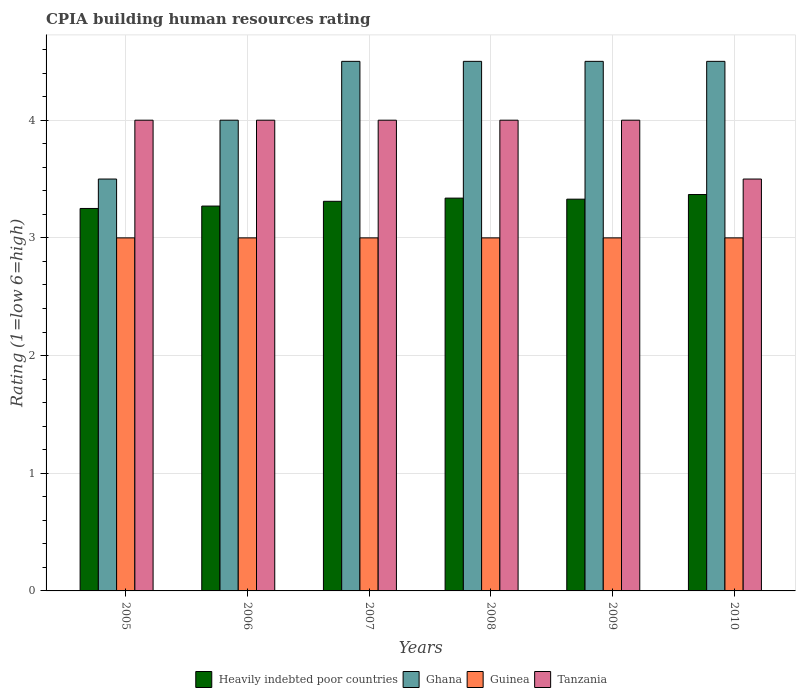Are the number of bars per tick equal to the number of legend labels?
Your response must be concise. Yes. Are the number of bars on each tick of the X-axis equal?
Keep it short and to the point. Yes. How many bars are there on the 5th tick from the left?
Provide a succinct answer. 4. What is the label of the 5th group of bars from the left?
Provide a short and direct response. 2009. What is the CPIA rating in Heavily indebted poor countries in 2009?
Give a very brief answer. 3.33. Across all years, what is the minimum CPIA rating in Tanzania?
Ensure brevity in your answer.  3.5. In which year was the CPIA rating in Guinea minimum?
Your response must be concise. 2005. What is the total CPIA rating in Tanzania in the graph?
Give a very brief answer. 23.5. What is the difference between the CPIA rating in Guinea in 2006 and that in 2008?
Offer a terse response. 0. What is the difference between the CPIA rating in Heavily indebted poor countries in 2008 and the CPIA rating in Ghana in 2006?
Ensure brevity in your answer.  -0.66. What is the average CPIA rating in Ghana per year?
Offer a terse response. 4.25. In the year 2008, what is the difference between the CPIA rating in Heavily indebted poor countries and CPIA rating in Guinea?
Keep it short and to the point. 0.34. In how many years, is the CPIA rating in Guinea greater than 0.6000000000000001?
Provide a succinct answer. 6. What is the ratio of the CPIA rating in Ghana in 2006 to that in 2007?
Your answer should be compact. 0.89. Is the difference between the CPIA rating in Heavily indebted poor countries in 2009 and 2010 greater than the difference between the CPIA rating in Guinea in 2009 and 2010?
Offer a terse response. No. What is the difference between the highest and the lowest CPIA rating in Tanzania?
Provide a succinct answer. 0.5. What does the 3rd bar from the right in 2009 represents?
Ensure brevity in your answer.  Ghana. How many years are there in the graph?
Your answer should be very brief. 6. Are the values on the major ticks of Y-axis written in scientific E-notation?
Your answer should be compact. No. Does the graph contain grids?
Give a very brief answer. Yes. What is the title of the graph?
Your response must be concise. CPIA building human resources rating. Does "Iraq" appear as one of the legend labels in the graph?
Offer a very short reply. No. What is the label or title of the Y-axis?
Give a very brief answer. Rating (1=low 6=high). What is the Rating (1=low 6=high) of Ghana in 2005?
Offer a very short reply. 3.5. What is the Rating (1=low 6=high) of Guinea in 2005?
Make the answer very short. 3. What is the Rating (1=low 6=high) of Tanzania in 2005?
Make the answer very short. 4. What is the Rating (1=low 6=high) of Heavily indebted poor countries in 2006?
Keep it short and to the point. 3.27. What is the Rating (1=low 6=high) of Heavily indebted poor countries in 2007?
Offer a very short reply. 3.31. What is the Rating (1=low 6=high) in Guinea in 2007?
Keep it short and to the point. 3. What is the Rating (1=low 6=high) of Heavily indebted poor countries in 2008?
Provide a short and direct response. 3.34. What is the Rating (1=low 6=high) in Tanzania in 2008?
Provide a succinct answer. 4. What is the Rating (1=low 6=high) in Heavily indebted poor countries in 2009?
Your answer should be very brief. 3.33. What is the Rating (1=low 6=high) in Ghana in 2009?
Offer a very short reply. 4.5. What is the Rating (1=low 6=high) in Heavily indebted poor countries in 2010?
Give a very brief answer. 3.37. What is the Rating (1=low 6=high) of Ghana in 2010?
Offer a very short reply. 4.5. What is the Rating (1=low 6=high) in Tanzania in 2010?
Your answer should be compact. 3.5. Across all years, what is the maximum Rating (1=low 6=high) of Heavily indebted poor countries?
Offer a terse response. 3.37. Across all years, what is the maximum Rating (1=low 6=high) in Ghana?
Make the answer very short. 4.5. Across all years, what is the maximum Rating (1=low 6=high) of Tanzania?
Your response must be concise. 4. Across all years, what is the minimum Rating (1=low 6=high) of Tanzania?
Make the answer very short. 3.5. What is the total Rating (1=low 6=high) in Heavily indebted poor countries in the graph?
Offer a terse response. 19.87. What is the total Rating (1=low 6=high) in Ghana in the graph?
Offer a terse response. 25.5. What is the total Rating (1=low 6=high) in Tanzania in the graph?
Make the answer very short. 23.5. What is the difference between the Rating (1=low 6=high) in Heavily indebted poor countries in 2005 and that in 2006?
Your answer should be very brief. -0.02. What is the difference between the Rating (1=low 6=high) of Tanzania in 2005 and that in 2006?
Ensure brevity in your answer.  0. What is the difference between the Rating (1=low 6=high) of Heavily indebted poor countries in 2005 and that in 2007?
Keep it short and to the point. -0.06. What is the difference between the Rating (1=low 6=high) of Ghana in 2005 and that in 2007?
Ensure brevity in your answer.  -1. What is the difference between the Rating (1=low 6=high) of Guinea in 2005 and that in 2007?
Provide a short and direct response. 0. What is the difference between the Rating (1=low 6=high) of Heavily indebted poor countries in 2005 and that in 2008?
Keep it short and to the point. -0.09. What is the difference between the Rating (1=low 6=high) in Ghana in 2005 and that in 2008?
Provide a short and direct response. -1. What is the difference between the Rating (1=low 6=high) in Tanzania in 2005 and that in 2008?
Ensure brevity in your answer.  0. What is the difference between the Rating (1=low 6=high) in Heavily indebted poor countries in 2005 and that in 2009?
Ensure brevity in your answer.  -0.08. What is the difference between the Rating (1=low 6=high) of Ghana in 2005 and that in 2009?
Provide a succinct answer. -1. What is the difference between the Rating (1=low 6=high) of Guinea in 2005 and that in 2009?
Your answer should be very brief. 0. What is the difference between the Rating (1=low 6=high) in Tanzania in 2005 and that in 2009?
Keep it short and to the point. 0. What is the difference between the Rating (1=low 6=high) of Heavily indebted poor countries in 2005 and that in 2010?
Provide a succinct answer. -0.12. What is the difference between the Rating (1=low 6=high) of Ghana in 2005 and that in 2010?
Give a very brief answer. -1. What is the difference between the Rating (1=low 6=high) of Tanzania in 2005 and that in 2010?
Provide a succinct answer. 0.5. What is the difference between the Rating (1=low 6=high) of Heavily indebted poor countries in 2006 and that in 2007?
Your answer should be compact. -0.04. What is the difference between the Rating (1=low 6=high) of Heavily indebted poor countries in 2006 and that in 2008?
Provide a succinct answer. -0.07. What is the difference between the Rating (1=low 6=high) in Guinea in 2006 and that in 2008?
Your answer should be compact. 0. What is the difference between the Rating (1=low 6=high) of Heavily indebted poor countries in 2006 and that in 2009?
Your response must be concise. -0.06. What is the difference between the Rating (1=low 6=high) of Guinea in 2006 and that in 2009?
Ensure brevity in your answer.  0. What is the difference between the Rating (1=low 6=high) of Heavily indebted poor countries in 2006 and that in 2010?
Offer a very short reply. -0.1. What is the difference between the Rating (1=low 6=high) of Ghana in 2006 and that in 2010?
Keep it short and to the point. -0.5. What is the difference between the Rating (1=low 6=high) in Tanzania in 2006 and that in 2010?
Provide a short and direct response. 0.5. What is the difference between the Rating (1=low 6=high) in Heavily indebted poor countries in 2007 and that in 2008?
Provide a short and direct response. -0.03. What is the difference between the Rating (1=low 6=high) of Guinea in 2007 and that in 2008?
Provide a short and direct response. 0. What is the difference between the Rating (1=low 6=high) in Tanzania in 2007 and that in 2008?
Provide a short and direct response. 0. What is the difference between the Rating (1=low 6=high) of Heavily indebted poor countries in 2007 and that in 2009?
Offer a very short reply. -0.02. What is the difference between the Rating (1=low 6=high) of Ghana in 2007 and that in 2009?
Offer a terse response. 0. What is the difference between the Rating (1=low 6=high) in Tanzania in 2007 and that in 2009?
Ensure brevity in your answer.  0. What is the difference between the Rating (1=low 6=high) in Heavily indebted poor countries in 2007 and that in 2010?
Keep it short and to the point. -0.06. What is the difference between the Rating (1=low 6=high) in Guinea in 2007 and that in 2010?
Provide a succinct answer. 0. What is the difference between the Rating (1=low 6=high) in Tanzania in 2007 and that in 2010?
Make the answer very short. 0.5. What is the difference between the Rating (1=low 6=high) in Heavily indebted poor countries in 2008 and that in 2009?
Make the answer very short. 0.01. What is the difference between the Rating (1=low 6=high) of Tanzania in 2008 and that in 2009?
Give a very brief answer. 0. What is the difference between the Rating (1=low 6=high) in Heavily indebted poor countries in 2008 and that in 2010?
Offer a very short reply. -0.03. What is the difference between the Rating (1=low 6=high) in Ghana in 2008 and that in 2010?
Provide a succinct answer. 0. What is the difference between the Rating (1=low 6=high) of Guinea in 2008 and that in 2010?
Your answer should be very brief. 0. What is the difference between the Rating (1=low 6=high) of Tanzania in 2008 and that in 2010?
Your answer should be very brief. 0.5. What is the difference between the Rating (1=low 6=high) in Heavily indebted poor countries in 2009 and that in 2010?
Provide a succinct answer. -0.04. What is the difference between the Rating (1=low 6=high) of Ghana in 2009 and that in 2010?
Offer a terse response. 0. What is the difference between the Rating (1=low 6=high) of Guinea in 2009 and that in 2010?
Provide a short and direct response. 0. What is the difference between the Rating (1=low 6=high) in Heavily indebted poor countries in 2005 and the Rating (1=low 6=high) in Ghana in 2006?
Make the answer very short. -0.75. What is the difference between the Rating (1=low 6=high) in Heavily indebted poor countries in 2005 and the Rating (1=low 6=high) in Tanzania in 2006?
Provide a short and direct response. -0.75. What is the difference between the Rating (1=low 6=high) in Ghana in 2005 and the Rating (1=low 6=high) in Guinea in 2006?
Your answer should be very brief. 0.5. What is the difference between the Rating (1=low 6=high) of Ghana in 2005 and the Rating (1=low 6=high) of Tanzania in 2006?
Offer a very short reply. -0.5. What is the difference between the Rating (1=low 6=high) in Guinea in 2005 and the Rating (1=low 6=high) in Tanzania in 2006?
Ensure brevity in your answer.  -1. What is the difference between the Rating (1=low 6=high) in Heavily indebted poor countries in 2005 and the Rating (1=low 6=high) in Ghana in 2007?
Your answer should be very brief. -1.25. What is the difference between the Rating (1=low 6=high) of Heavily indebted poor countries in 2005 and the Rating (1=low 6=high) of Tanzania in 2007?
Your answer should be compact. -0.75. What is the difference between the Rating (1=low 6=high) in Ghana in 2005 and the Rating (1=low 6=high) in Guinea in 2007?
Provide a succinct answer. 0.5. What is the difference between the Rating (1=low 6=high) in Ghana in 2005 and the Rating (1=low 6=high) in Tanzania in 2007?
Keep it short and to the point. -0.5. What is the difference between the Rating (1=low 6=high) in Heavily indebted poor countries in 2005 and the Rating (1=low 6=high) in Ghana in 2008?
Make the answer very short. -1.25. What is the difference between the Rating (1=low 6=high) in Heavily indebted poor countries in 2005 and the Rating (1=low 6=high) in Guinea in 2008?
Offer a terse response. 0.25. What is the difference between the Rating (1=low 6=high) in Heavily indebted poor countries in 2005 and the Rating (1=low 6=high) in Tanzania in 2008?
Offer a very short reply. -0.75. What is the difference between the Rating (1=low 6=high) of Ghana in 2005 and the Rating (1=low 6=high) of Tanzania in 2008?
Offer a very short reply. -0.5. What is the difference between the Rating (1=low 6=high) of Heavily indebted poor countries in 2005 and the Rating (1=low 6=high) of Ghana in 2009?
Ensure brevity in your answer.  -1.25. What is the difference between the Rating (1=low 6=high) of Heavily indebted poor countries in 2005 and the Rating (1=low 6=high) of Tanzania in 2009?
Offer a terse response. -0.75. What is the difference between the Rating (1=low 6=high) of Ghana in 2005 and the Rating (1=low 6=high) of Guinea in 2009?
Offer a very short reply. 0.5. What is the difference between the Rating (1=low 6=high) of Ghana in 2005 and the Rating (1=low 6=high) of Tanzania in 2009?
Your answer should be very brief. -0.5. What is the difference between the Rating (1=low 6=high) in Guinea in 2005 and the Rating (1=low 6=high) in Tanzania in 2009?
Make the answer very short. -1. What is the difference between the Rating (1=low 6=high) of Heavily indebted poor countries in 2005 and the Rating (1=low 6=high) of Ghana in 2010?
Ensure brevity in your answer.  -1.25. What is the difference between the Rating (1=low 6=high) in Ghana in 2005 and the Rating (1=low 6=high) in Guinea in 2010?
Give a very brief answer. 0.5. What is the difference between the Rating (1=low 6=high) of Heavily indebted poor countries in 2006 and the Rating (1=low 6=high) of Ghana in 2007?
Offer a terse response. -1.23. What is the difference between the Rating (1=low 6=high) of Heavily indebted poor countries in 2006 and the Rating (1=low 6=high) of Guinea in 2007?
Your answer should be very brief. 0.27. What is the difference between the Rating (1=low 6=high) of Heavily indebted poor countries in 2006 and the Rating (1=low 6=high) of Tanzania in 2007?
Provide a short and direct response. -0.73. What is the difference between the Rating (1=low 6=high) of Heavily indebted poor countries in 2006 and the Rating (1=low 6=high) of Ghana in 2008?
Your answer should be very brief. -1.23. What is the difference between the Rating (1=low 6=high) of Heavily indebted poor countries in 2006 and the Rating (1=low 6=high) of Guinea in 2008?
Provide a succinct answer. 0.27. What is the difference between the Rating (1=low 6=high) of Heavily indebted poor countries in 2006 and the Rating (1=low 6=high) of Tanzania in 2008?
Keep it short and to the point. -0.73. What is the difference between the Rating (1=low 6=high) in Ghana in 2006 and the Rating (1=low 6=high) in Guinea in 2008?
Provide a short and direct response. 1. What is the difference between the Rating (1=low 6=high) in Guinea in 2006 and the Rating (1=low 6=high) in Tanzania in 2008?
Ensure brevity in your answer.  -1. What is the difference between the Rating (1=low 6=high) in Heavily indebted poor countries in 2006 and the Rating (1=low 6=high) in Ghana in 2009?
Ensure brevity in your answer.  -1.23. What is the difference between the Rating (1=low 6=high) of Heavily indebted poor countries in 2006 and the Rating (1=low 6=high) of Guinea in 2009?
Provide a succinct answer. 0.27. What is the difference between the Rating (1=low 6=high) in Heavily indebted poor countries in 2006 and the Rating (1=low 6=high) in Tanzania in 2009?
Your answer should be very brief. -0.73. What is the difference between the Rating (1=low 6=high) of Ghana in 2006 and the Rating (1=low 6=high) of Tanzania in 2009?
Offer a very short reply. 0. What is the difference between the Rating (1=low 6=high) of Guinea in 2006 and the Rating (1=low 6=high) of Tanzania in 2009?
Give a very brief answer. -1. What is the difference between the Rating (1=low 6=high) in Heavily indebted poor countries in 2006 and the Rating (1=low 6=high) in Ghana in 2010?
Your response must be concise. -1.23. What is the difference between the Rating (1=low 6=high) of Heavily indebted poor countries in 2006 and the Rating (1=low 6=high) of Guinea in 2010?
Your answer should be compact. 0.27. What is the difference between the Rating (1=low 6=high) of Heavily indebted poor countries in 2006 and the Rating (1=low 6=high) of Tanzania in 2010?
Ensure brevity in your answer.  -0.23. What is the difference between the Rating (1=low 6=high) in Ghana in 2006 and the Rating (1=low 6=high) in Tanzania in 2010?
Keep it short and to the point. 0.5. What is the difference between the Rating (1=low 6=high) in Guinea in 2006 and the Rating (1=low 6=high) in Tanzania in 2010?
Ensure brevity in your answer.  -0.5. What is the difference between the Rating (1=low 6=high) in Heavily indebted poor countries in 2007 and the Rating (1=low 6=high) in Ghana in 2008?
Offer a very short reply. -1.19. What is the difference between the Rating (1=low 6=high) of Heavily indebted poor countries in 2007 and the Rating (1=low 6=high) of Guinea in 2008?
Your answer should be very brief. 0.31. What is the difference between the Rating (1=low 6=high) of Heavily indebted poor countries in 2007 and the Rating (1=low 6=high) of Tanzania in 2008?
Give a very brief answer. -0.69. What is the difference between the Rating (1=low 6=high) of Ghana in 2007 and the Rating (1=low 6=high) of Guinea in 2008?
Ensure brevity in your answer.  1.5. What is the difference between the Rating (1=low 6=high) of Ghana in 2007 and the Rating (1=low 6=high) of Tanzania in 2008?
Offer a terse response. 0.5. What is the difference between the Rating (1=low 6=high) of Heavily indebted poor countries in 2007 and the Rating (1=low 6=high) of Ghana in 2009?
Make the answer very short. -1.19. What is the difference between the Rating (1=low 6=high) of Heavily indebted poor countries in 2007 and the Rating (1=low 6=high) of Guinea in 2009?
Keep it short and to the point. 0.31. What is the difference between the Rating (1=low 6=high) in Heavily indebted poor countries in 2007 and the Rating (1=low 6=high) in Tanzania in 2009?
Keep it short and to the point. -0.69. What is the difference between the Rating (1=low 6=high) of Ghana in 2007 and the Rating (1=low 6=high) of Guinea in 2009?
Offer a terse response. 1.5. What is the difference between the Rating (1=low 6=high) in Ghana in 2007 and the Rating (1=low 6=high) in Tanzania in 2009?
Your answer should be very brief. 0.5. What is the difference between the Rating (1=low 6=high) of Heavily indebted poor countries in 2007 and the Rating (1=low 6=high) of Ghana in 2010?
Offer a terse response. -1.19. What is the difference between the Rating (1=low 6=high) of Heavily indebted poor countries in 2007 and the Rating (1=low 6=high) of Guinea in 2010?
Your response must be concise. 0.31. What is the difference between the Rating (1=low 6=high) in Heavily indebted poor countries in 2007 and the Rating (1=low 6=high) in Tanzania in 2010?
Offer a terse response. -0.19. What is the difference between the Rating (1=low 6=high) in Guinea in 2007 and the Rating (1=low 6=high) in Tanzania in 2010?
Provide a short and direct response. -0.5. What is the difference between the Rating (1=low 6=high) of Heavily indebted poor countries in 2008 and the Rating (1=low 6=high) of Ghana in 2009?
Your answer should be compact. -1.16. What is the difference between the Rating (1=low 6=high) of Heavily indebted poor countries in 2008 and the Rating (1=low 6=high) of Guinea in 2009?
Your answer should be compact. 0.34. What is the difference between the Rating (1=low 6=high) of Heavily indebted poor countries in 2008 and the Rating (1=low 6=high) of Tanzania in 2009?
Make the answer very short. -0.66. What is the difference between the Rating (1=low 6=high) in Ghana in 2008 and the Rating (1=low 6=high) in Tanzania in 2009?
Your answer should be compact. 0.5. What is the difference between the Rating (1=low 6=high) in Heavily indebted poor countries in 2008 and the Rating (1=low 6=high) in Ghana in 2010?
Your answer should be compact. -1.16. What is the difference between the Rating (1=low 6=high) of Heavily indebted poor countries in 2008 and the Rating (1=low 6=high) of Guinea in 2010?
Offer a very short reply. 0.34. What is the difference between the Rating (1=low 6=high) in Heavily indebted poor countries in 2008 and the Rating (1=low 6=high) in Tanzania in 2010?
Your answer should be very brief. -0.16. What is the difference between the Rating (1=low 6=high) in Ghana in 2008 and the Rating (1=low 6=high) in Tanzania in 2010?
Your answer should be compact. 1. What is the difference between the Rating (1=low 6=high) in Guinea in 2008 and the Rating (1=low 6=high) in Tanzania in 2010?
Offer a terse response. -0.5. What is the difference between the Rating (1=low 6=high) of Heavily indebted poor countries in 2009 and the Rating (1=low 6=high) of Ghana in 2010?
Your answer should be very brief. -1.17. What is the difference between the Rating (1=low 6=high) in Heavily indebted poor countries in 2009 and the Rating (1=low 6=high) in Guinea in 2010?
Keep it short and to the point. 0.33. What is the difference between the Rating (1=low 6=high) of Heavily indebted poor countries in 2009 and the Rating (1=low 6=high) of Tanzania in 2010?
Provide a short and direct response. -0.17. What is the difference between the Rating (1=low 6=high) of Ghana in 2009 and the Rating (1=low 6=high) of Tanzania in 2010?
Provide a short and direct response. 1. What is the average Rating (1=low 6=high) of Heavily indebted poor countries per year?
Keep it short and to the point. 3.31. What is the average Rating (1=low 6=high) of Ghana per year?
Offer a very short reply. 4.25. What is the average Rating (1=low 6=high) in Tanzania per year?
Offer a terse response. 3.92. In the year 2005, what is the difference between the Rating (1=low 6=high) in Heavily indebted poor countries and Rating (1=low 6=high) in Guinea?
Offer a very short reply. 0.25. In the year 2005, what is the difference between the Rating (1=low 6=high) of Heavily indebted poor countries and Rating (1=low 6=high) of Tanzania?
Provide a short and direct response. -0.75. In the year 2005, what is the difference between the Rating (1=low 6=high) in Guinea and Rating (1=low 6=high) in Tanzania?
Your answer should be compact. -1. In the year 2006, what is the difference between the Rating (1=low 6=high) in Heavily indebted poor countries and Rating (1=low 6=high) in Ghana?
Offer a very short reply. -0.73. In the year 2006, what is the difference between the Rating (1=low 6=high) in Heavily indebted poor countries and Rating (1=low 6=high) in Guinea?
Give a very brief answer. 0.27. In the year 2006, what is the difference between the Rating (1=low 6=high) in Heavily indebted poor countries and Rating (1=low 6=high) in Tanzania?
Give a very brief answer. -0.73. In the year 2006, what is the difference between the Rating (1=low 6=high) in Ghana and Rating (1=low 6=high) in Tanzania?
Make the answer very short. 0. In the year 2006, what is the difference between the Rating (1=low 6=high) of Guinea and Rating (1=low 6=high) of Tanzania?
Provide a short and direct response. -1. In the year 2007, what is the difference between the Rating (1=low 6=high) of Heavily indebted poor countries and Rating (1=low 6=high) of Ghana?
Give a very brief answer. -1.19. In the year 2007, what is the difference between the Rating (1=low 6=high) of Heavily indebted poor countries and Rating (1=low 6=high) of Guinea?
Your answer should be very brief. 0.31. In the year 2007, what is the difference between the Rating (1=low 6=high) in Heavily indebted poor countries and Rating (1=low 6=high) in Tanzania?
Offer a terse response. -0.69. In the year 2007, what is the difference between the Rating (1=low 6=high) of Ghana and Rating (1=low 6=high) of Guinea?
Your response must be concise. 1.5. In the year 2007, what is the difference between the Rating (1=low 6=high) of Guinea and Rating (1=low 6=high) of Tanzania?
Provide a succinct answer. -1. In the year 2008, what is the difference between the Rating (1=low 6=high) of Heavily indebted poor countries and Rating (1=low 6=high) of Ghana?
Offer a very short reply. -1.16. In the year 2008, what is the difference between the Rating (1=low 6=high) in Heavily indebted poor countries and Rating (1=low 6=high) in Guinea?
Your response must be concise. 0.34. In the year 2008, what is the difference between the Rating (1=low 6=high) of Heavily indebted poor countries and Rating (1=low 6=high) of Tanzania?
Make the answer very short. -0.66. In the year 2008, what is the difference between the Rating (1=low 6=high) of Ghana and Rating (1=low 6=high) of Tanzania?
Offer a very short reply. 0.5. In the year 2008, what is the difference between the Rating (1=low 6=high) of Guinea and Rating (1=low 6=high) of Tanzania?
Make the answer very short. -1. In the year 2009, what is the difference between the Rating (1=low 6=high) of Heavily indebted poor countries and Rating (1=low 6=high) of Ghana?
Your answer should be compact. -1.17. In the year 2009, what is the difference between the Rating (1=low 6=high) of Heavily indebted poor countries and Rating (1=low 6=high) of Guinea?
Offer a terse response. 0.33. In the year 2009, what is the difference between the Rating (1=low 6=high) of Heavily indebted poor countries and Rating (1=low 6=high) of Tanzania?
Provide a succinct answer. -0.67. In the year 2009, what is the difference between the Rating (1=low 6=high) in Guinea and Rating (1=low 6=high) in Tanzania?
Give a very brief answer. -1. In the year 2010, what is the difference between the Rating (1=low 6=high) in Heavily indebted poor countries and Rating (1=low 6=high) in Ghana?
Your response must be concise. -1.13. In the year 2010, what is the difference between the Rating (1=low 6=high) of Heavily indebted poor countries and Rating (1=low 6=high) of Guinea?
Provide a short and direct response. 0.37. In the year 2010, what is the difference between the Rating (1=low 6=high) of Heavily indebted poor countries and Rating (1=low 6=high) of Tanzania?
Your answer should be compact. -0.13. In the year 2010, what is the difference between the Rating (1=low 6=high) of Ghana and Rating (1=low 6=high) of Guinea?
Provide a short and direct response. 1.5. In the year 2010, what is the difference between the Rating (1=low 6=high) in Ghana and Rating (1=low 6=high) in Tanzania?
Give a very brief answer. 1. In the year 2010, what is the difference between the Rating (1=low 6=high) in Guinea and Rating (1=low 6=high) in Tanzania?
Provide a succinct answer. -0.5. What is the ratio of the Rating (1=low 6=high) in Tanzania in 2005 to that in 2006?
Offer a terse response. 1. What is the ratio of the Rating (1=low 6=high) of Heavily indebted poor countries in 2005 to that in 2007?
Give a very brief answer. 0.98. What is the ratio of the Rating (1=low 6=high) of Ghana in 2005 to that in 2007?
Provide a succinct answer. 0.78. What is the ratio of the Rating (1=low 6=high) in Guinea in 2005 to that in 2007?
Your response must be concise. 1. What is the ratio of the Rating (1=low 6=high) of Heavily indebted poor countries in 2005 to that in 2008?
Your answer should be compact. 0.97. What is the ratio of the Rating (1=low 6=high) of Tanzania in 2005 to that in 2008?
Provide a succinct answer. 1. What is the ratio of the Rating (1=low 6=high) of Heavily indebted poor countries in 2005 to that in 2009?
Ensure brevity in your answer.  0.98. What is the ratio of the Rating (1=low 6=high) of Guinea in 2005 to that in 2009?
Make the answer very short. 1. What is the ratio of the Rating (1=low 6=high) in Tanzania in 2005 to that in 2009?
Keep it short and to the point. 1. What is the ratio of the Rating (1=low 6=high) of Heavily indebted poor countries in 2005 to that in 2010?
Provide a succinct answer. 0.96. What is the ratio of the Rating (1=low 6=high) in Guinea in 2005 to that in 2010?
Ensure brevity in your answer.  1. What is the ratio of the Rating (1=low 6=high) of Tanzania in 2005 to that in 2010?
Offer a very short reply. 1.14. What is the ratio of the Rating (1=low 6=high) in Heavily indebted poor countries in 2006 to that in 2007?
Offer a very short reply. 0.99. What is the ratio of the Rating (1=low 6=high) in Guinea in 2006 to that in 2007?
Your response must be concise. 1. What is the ratio of the Rating (1=low 6=high) in Heavily indebted poor countries in 2006 to that in 2008?
Make the answer very short. 0.98. What is the ratio of the Rating (1=low 6=high) in Guinea in 2006 to that in 2008?
Offer a terse response. 1. What is the ratio of the Rating (1=low 6=high) of Tanzania in 2006 to that in 2008?
Make the answer very short. 1. What is the ratio of the Rating (1=low 6=high) of Heavily indebted poor countries in 2006 to that in 2009?
Ensure brevity in your answer.  0.98. What is the ratio of the Rating (1=low 6=high) of Tanzania in 2006 to that in 2009?
Your answer should be compact. 1. What is the ratio of the Rating (1=low 6=high) of Heavily indebted poor countries in 2006 to that in 2010?
Give a very brief answer. 0.97. What is the ratio of the Rating (1=low 6=high) in Tanzania in 2006 to that in 2010?
Provide a succinct answer. 1.14. What is the ratio of the Rating (1=low 6=high) in Heavily indebted poor countries in 2007 to that in 2008?
Your response must be concise. 0.99. What is the ratio of the Rating (1=low 6=high) of Ghana in 2007 to that in 2008?
Your response must be concise. 1. What is the ratio of the Rating (1=low 6=high) of Guinea in 2007 to that in 2008?
Provide a short and direct response. 1. What is the ratio of the Rating (1=low 6=high) of Tanzania in 2007 to that in 2008?
Provide a short and direct response. 1. What is the ratio of the Rating (1=low 6=high) of Ghana in 2007 to that in 2009?
Provide a short and direct response. 1. What is the ratio of the Rating (1=low 6=high) in Tanzania in 2007 to that in 2009?
Keep it short and to the point. 1. What is the ratio of the Rating (1=low 6=high) in Heavily indebted poor countries in 2007 to that in 2010?
Your answer should be compact. 0.98. What is the ratio of the Rating (1=low 6=high) of Ghana in 2007 to that in 2010?
Keep it short and to the point. 1. What is the ratio of the Rating (1=low 6=high) of Guinea in 2007 to that in 2010?
Offer a terse response. 1. What is the ratio of the Rating (1=low 6=high) in Tanzania in 2007 to that in 2010?
Make the answer very short. 1.14. What is the ratio of the Rating (1=low 6=high) of Heavily indebted poor countries in 2008 to that in 2009?
Give a very brief answer. 1. What is the ratio of the Rating (1=low 6=high) of Ghana in 2008 to that in 2009?
Make the answer very short. 1. What is the ratio of the Rating (1=low 6=high) of Guinea in 2008 to that in 2009?
Offer a very short reply. 1. What is the ratio of the Rating (1=low 6=high) in Tanzania in 2008 to that in 2009?
Offer a terse response. 1. What is the ratio of the Rating (1=low 6=high) of Heavily indebted poor countries in 2008 to that in 2010?
Provide a short and direct response. 0.99. What is the ratio of the Rating (1=low 6=high) in Heavily indebted poor countries in 2009 to that in 2010?
Give a very brief answer. 0.99. What is the ratio of the Rating (1=low 6=high) in Ghana in 2009 to that in 2010?
Make the answer very short. 1. What is the ratio of the Rating (1=low 6=high) of Tanzania in 2009 to that in 2010?
Provide a short and direct response. 1.14. What is the difference between the highest and the second highest Rating (1=low 6=high) in Heavily indebted poor countries?
Make the answer very short. 0.03. What is the difference between the highest and the second highest Rating (1=low 6=high) of Guinea?
Ensure brevity in your answer.  0. What is the difference between the highest and the second highest Rating (1=low 6=high) in Tanzania?
Make the answer very short. 0. What is the difference between the highest and the lowest Rating (1=low 6=high) in Heavily indebted poor countries?
Keep it short and to the point. 0.12. What is the difference between the highest and the lowest Rating (1=low 6=high) of Ghana?
Your response must be concise. 1. What is the difference between the highest and the lowest Rating (1=low 6=high) of Tanzania?
Provide a succinct answer. 0.5. 